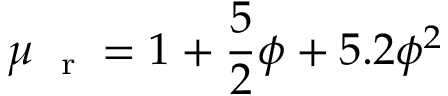Convert formula to latex. <formula><loc_0><loc_0><loc_500><loc_500>\mu _ { r } = 1 + \frac { 5 } { 2 } \phi + 5 . 2 \phi ^ { 2 }</formula> 